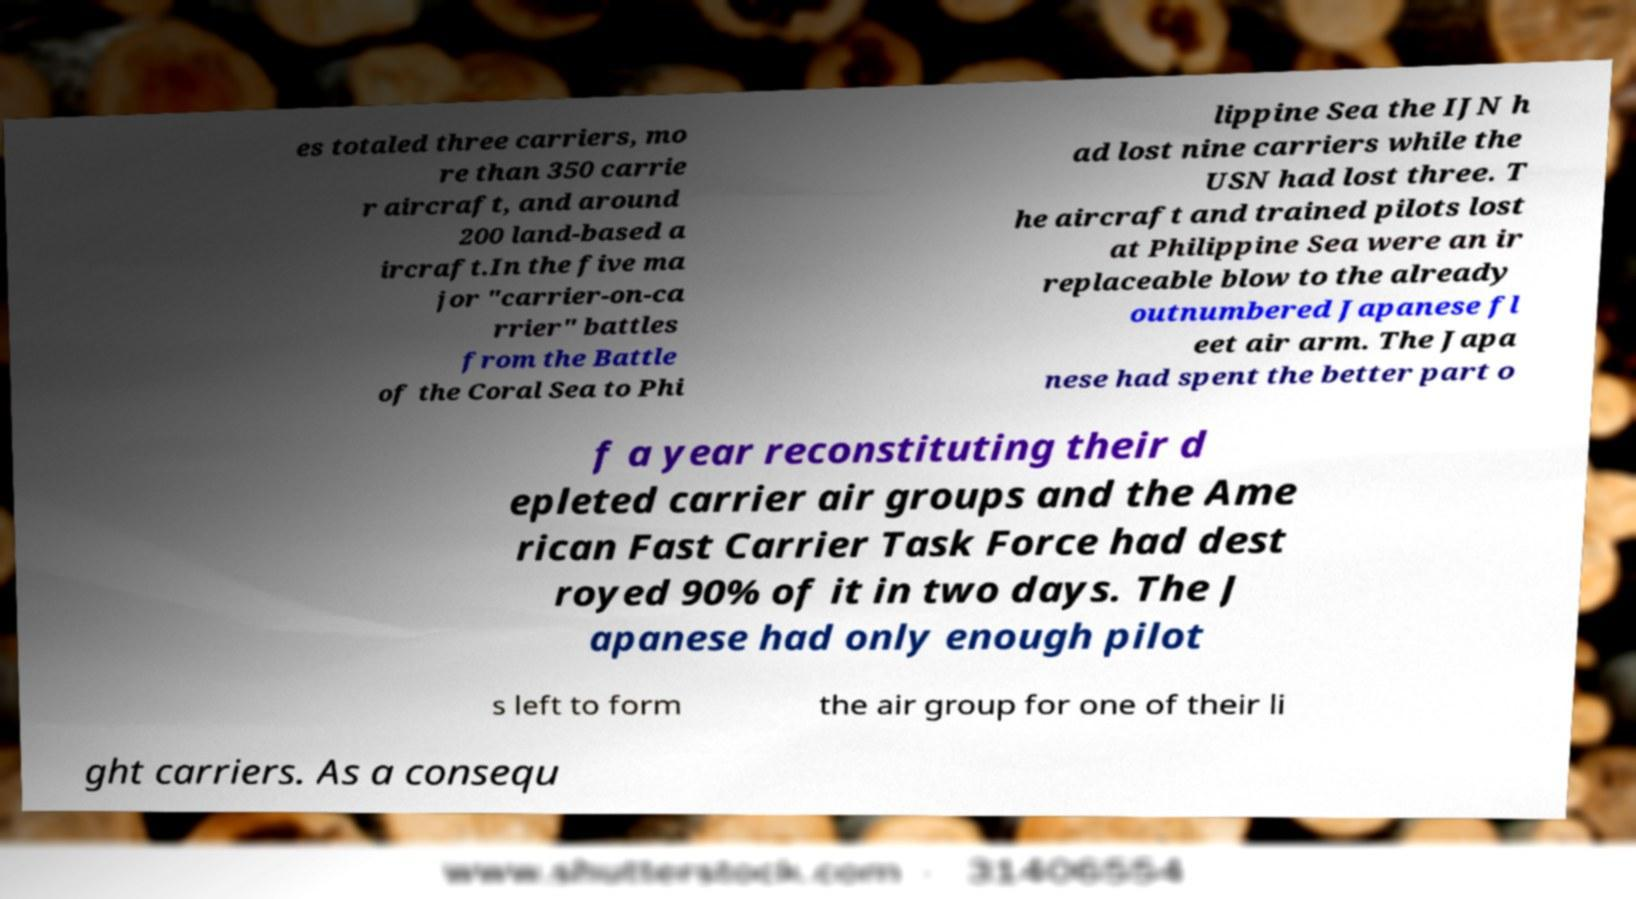Could you assist in decoding the text presented in this image and type it out clearly? es totaled three carriers, mo re than 350 carrie r aircraft, and around 200 land-based a ircraft.In the five ma jor "carrier-on-ca rrier" battles from the Battle of the Coral Sea to Phi lippine Sea the IJN h ad lost nine carriers while the USN had lost three. T he aircraft and trained pilots lost at Philippine Sea were an ir replaceable blow to the already outnumbered Japanese fl eet air arm. The Japa nese had spent the better part o f a year reconstituting their d epleted carrier air groups and the Ame rican Fast Carrier Task Force had dest royed 90% of it in two days. The J apanese had only enough pilot s left to form the air group for one of their li ght carriers. As a consequ 